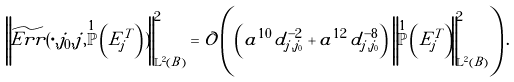<formula> <loc_0><loc_0><loc_500><loc_500>\left \| \widetilde { E r r } ( \cdot , j _ { 0 } , j , \overset { 1 } { \mathbb { P } } \left ( E _ { j } ^ { T } \right ) ) \right \| ^ { 2 } _ { \mathbb { L } ^ { 2 } ( B ) } = \mathcal { O } \left ( \left ( a ^ { 1 0 } \, d ^ { - 2 } _ { j , j _ { 0 } } + a ^ { 1 2 } \, d ^ { - 8 } _ { j , j _ { 0 } } \right ) \, \left \| \overset { 1 } { \mathbb { P } } \left ( \tilde { E } _ { j } ^ { T } \right ) \right \| ^ { 2 } _ { \mathbb { L } ^ { 2 } ( B ) } \right ) .</formula> 